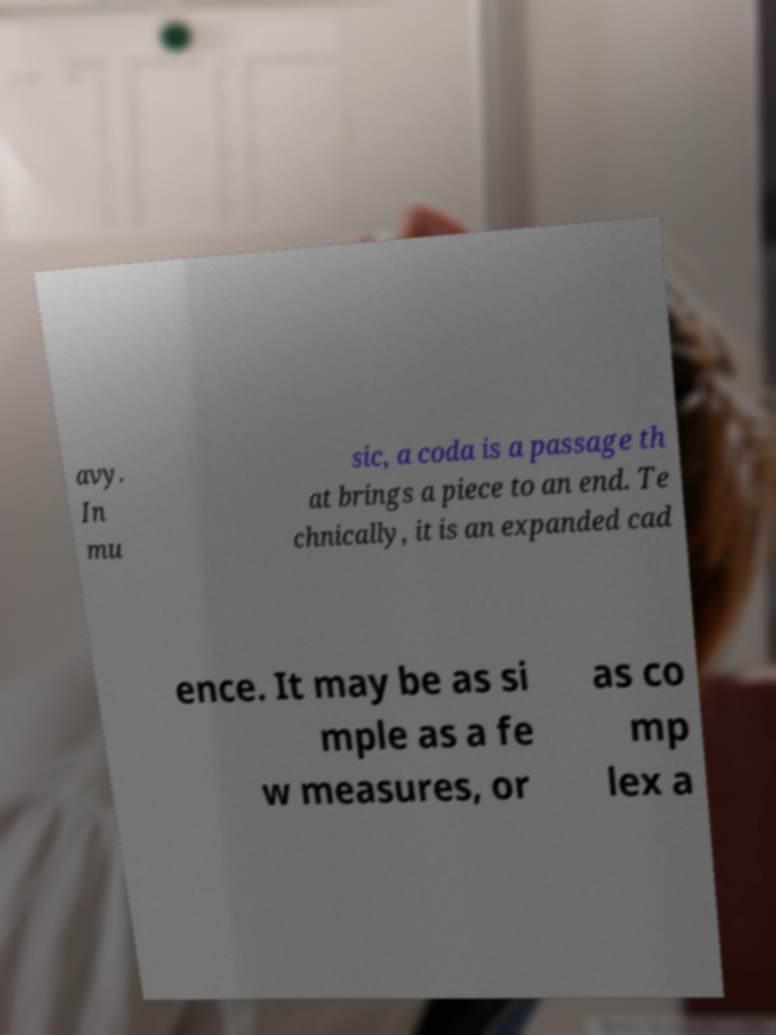What messages or text are displayed in this image? I need them in a readable, typed format. avy. In mu sic, a coda is a passage th at brings a piece to an end. Te chnically, it is an expanded cad ence. It may be as si mple as a fe w measures, or as co mp lex a 